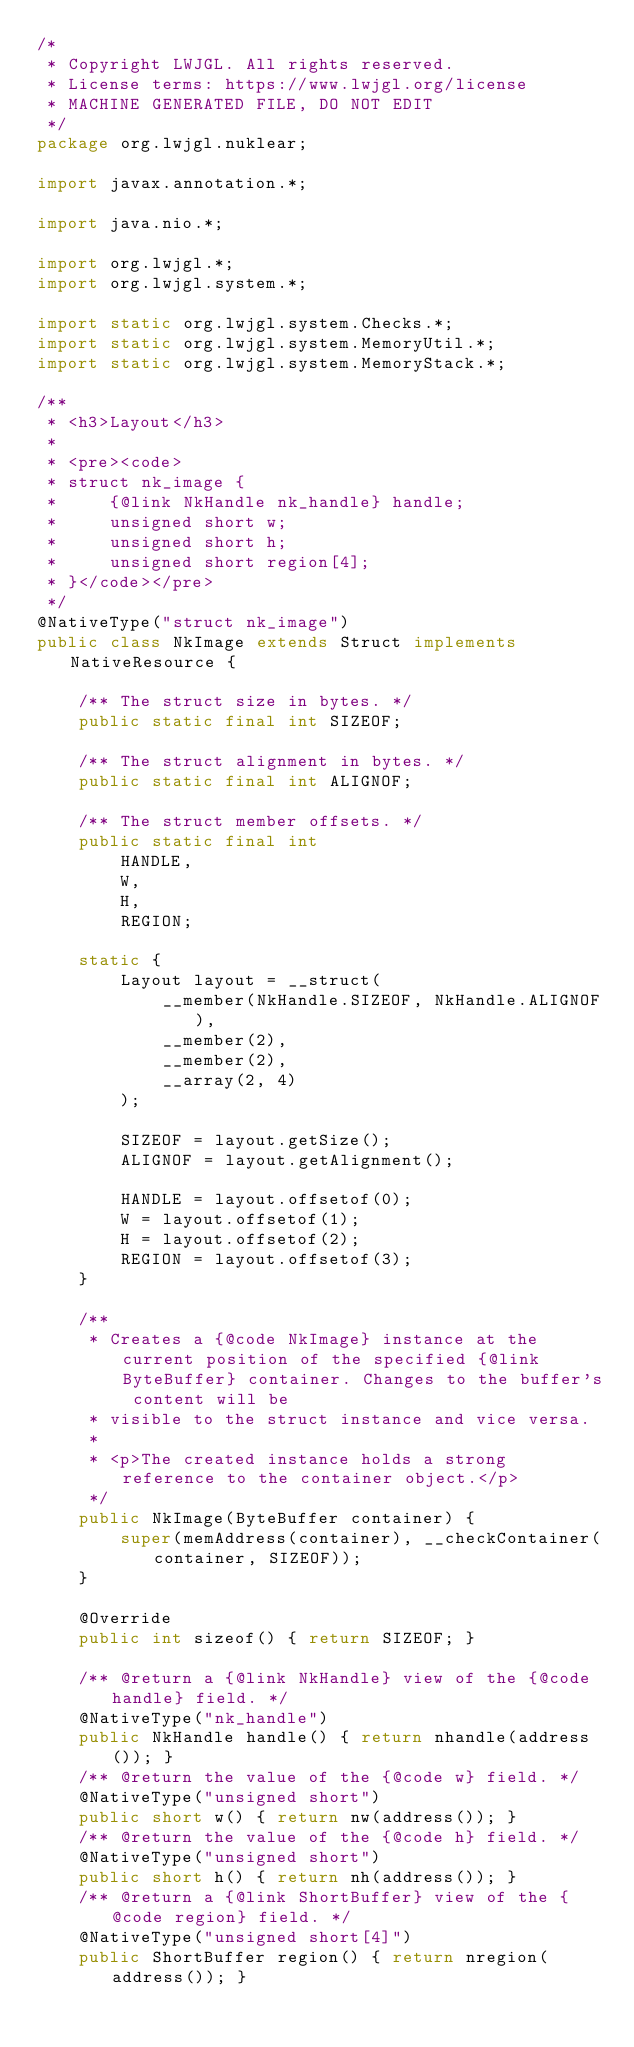<code> <loc_0><loc_0><loc_500><loc_500><_Java_>/*
 * Copyright LWJGL. All rights reserved.
 * License terms: https://www.lwjgl.org/license
 * MACHINE GENERATED FILE, DO NOT EDIT
 */
package org.lwjgl.nuklear;

import javax.annotation.*;

import java.nio.*;

import org.lwjgl.*;
import org.lwjgl.system.*;

import static org.lwjgl.system.Checks.*;
import static org.lwjgl.system.MemoryUtil.*;
import static org.lwjgl.system.MemoryStack.*;

/**
 * <h3>Layout</h3>
 * 
 * <pre><code>
 * struct nk_image {
 *     {@link NkHandle nk_handle} handle;
 *     unsigned short w;
 *     unsigned short h;
 *     unsigned short region[4];
 * }</code></pre>
 */
@NativeType("struct nk_image")
public class NkImage extends Struct implements NativeResource {

    /** The struct size in bytes. */
    public static final int SIZEOF;

    /** The struct alignment in bytes. */
    public static final int ALIGNOF;

    /** The struct member offsets. */
    public static final int
        HANDLE,
        W,
        H,
        REGION;

    static {
        Layout layout = __struct(
            __member(NkHandle.SIZEOF, NkHandle.ALIGNOF),
            __member(2),
            __member(2),
            __array(2, 4)
        );

        SIZEOF = layout.getSize();
        ALIGNOF = layout.getAlignment();

        HANDLE = layout.offsetof(0);
        W = layout.offsetof(1);
        H = layout.offsetof(2);
        REGION = layout.offsetof(3);
    }

    /**
     * Creates a {@code NkImage} instance at the current position of the specified {@link ByteBuffer} container. Changes to the buffer's content will be
     * visible to the struct instance and vice versa.
     *
     * <p>The created instance holds a strong reference to the container object.</p>
     */
    public NkImage(ByteBuffer container) {
        super(memAddress(container), __checkContainer(container, SIZEOF));
    }

    @Override
    public int sizeof() { return SIZEOF; }

    /** @return a {@link NkHandle} view of the {@code handle} field. */
    @NativeType("nk_handle")
    public NkHandle handle() { return nhandle(address()); }
    /** @return the value of the {@code w} field. */
    @NativeType("unsigned short")
    public short w() { return nw(address()); }
    /** @return the value of the {@code h} field. */
    @NativeType("unsigned short")
    public short h() { return nh(address()); }
    /** @return a {@link ShortBuffer} view of the {@code region} field. */
    @NativeType("unsigned short[4]")
    public ShortBuffer region() { return nregion(address()); }</code> 